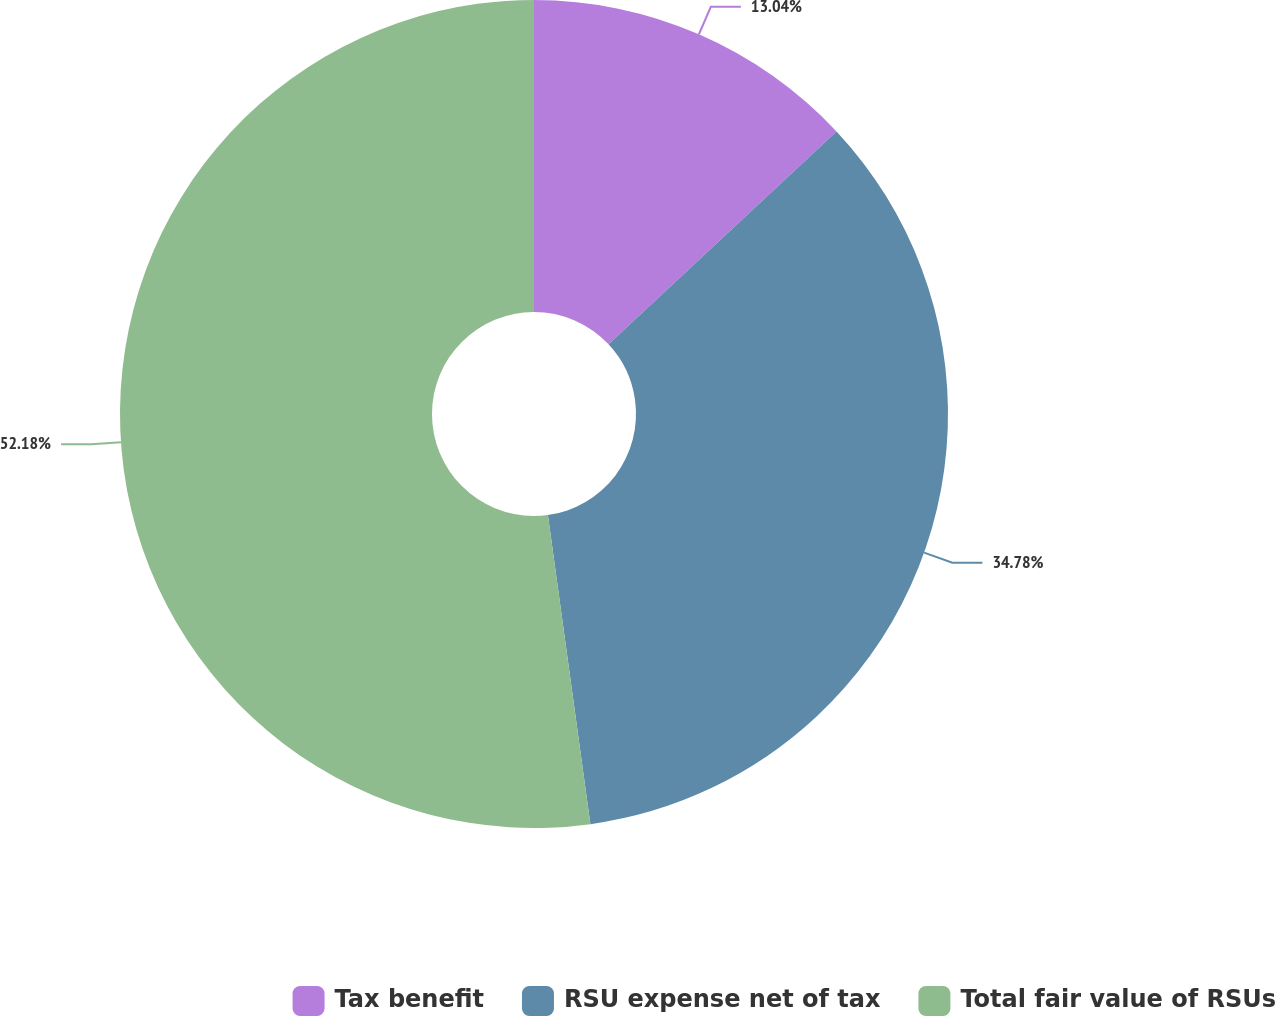Convert chart to OTSL. <chart><loc_0><loc_0><loc_500><loc_500><pie_chart><fcel>Tax benefit<fcel>RSU expense net of tax<fcel>Total fair value of RSUs<nl><fcel>13.04%<fcel>34.78%<fcel>52.17%<nl></chart> 